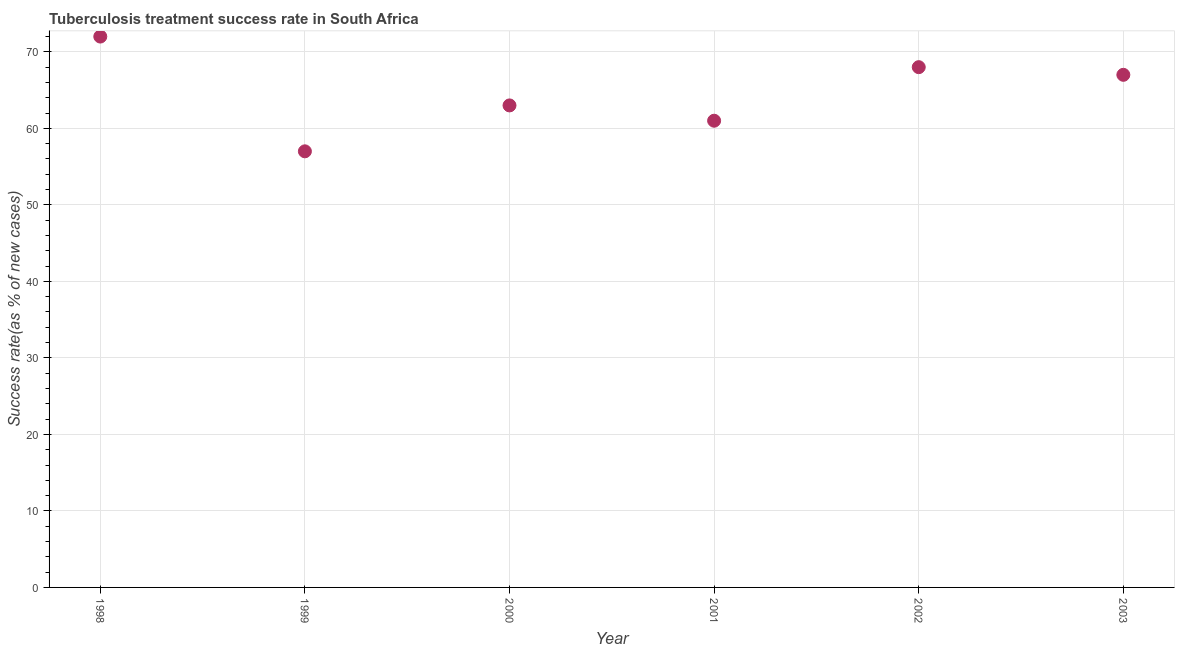What is the tuberculosis treatment success rate in 2002?
Provide a short and direct response. 68. Across all years, what is the maximum tuberculosis treatment success rate?
Give a very brief answer. 72. Across all years, what is the minimum tuberculosis treatment success rate?
Offer a very short reply. 57. In which year was the tuberculosis treatment success rate maximum?
Provide a succinct answer. 1998. What is the sum of the tuberculosis treatment success rate?
Give a very brief answer. 388. What is the difference between the tuberculosis treatment success rate in 1998 and 2000?
Keep it short and to the point. 9. What is the average tuberculosis treatment success rate per year?
Provide a succinct answer. 64.67. In how many years, is the tuberculosis treatment success rate greater than 16 %?
Provide a succinct answer. 6. Do a majority of the years between 1999 and 1998 (inclusive) have tuberculosis treatment success rate greater than 56 %?
Your answer should be very brief. No. What is the ratio of the tuberculosis treatment success rate in 2001 to that in 2003?
Ensure brevity in your answer.  0.91. Is the difference between the tuberculosis treatment success rate in 2002 and 2003 greater than the difference between any two years?
Offer a terse response. No. What is the difference between the highest and the second highest tuberculosis treatment success rate?
Offer a very short reply. 4. What is the difference between the highest and the lowest tuberculosis treatment success rate?
Keep it short and to the point. 15. Does the tuberculosis treatment success rate monotonically increase over the years?
Give a very brief answer. No. How many dotlines are there?
Make the answer very short. 1. How many years are there in the graph?
Your answer should be compact. 6. Does the graph contain any zero values?
Your answer should be very brief. No. Does the graph contain grids?
Give a very brief answer. Yes. What is the title of the graph?
Ensure brevity in your answer.  Tuberculosis treatment success rate in South Africa. What is the label or title of the X-axis?
Your answer should be very brief. Year. What is the label or title of the Y-axis?
Provide a succinct answer. Success rate(as % of new cases). What is the Success rate(as % of new cases) in 1999?
Your answer should be very brief. 57. What is the Success rate(as % of new cases) in 2000?
Your response must be concise. 63. What is the Success rate(as % of new cases) in 2001?
Offer a terse response. 61. What is the Success rate(as % of new cases) in 2002?
Give a very brief answer. 68. What is the Success rate(as % of new cases) in 2003?
Your answer should be very brief. 67. What is the difference between the Success rate(as % of new cases) in 1998 and 1999?
Your answer should be very brief. 15. What is the difference between the Success rate(as % of new cases) in 1998 and 2000?
Offer a terse response. 9. What is the difference between the Success rate(as % of new cases) in 1998 and 2002?
Offer a terse response. 4. What is the difference between the Success rate(as % of new cases) in 1999 and 2000?
Offer a terse response. -6. What is the difference between the Success rate(as % of new cases) in 1999 and 2001?
Offer a very short reply. -4. What is the difference between the Success rate(as % of new cases) in 1999 and 2003?
Provide a short and direct response. -10. What is the difference between the Success rate(as % of new cases) in 2001 and 2003?
Make the answer very short. -6. What is the difference between the Success rate(as % of new cases) in 2002 and 2003?
Provide a short and direct response. 1. What is the ratio of the Success rate(as % of new cases) in 1998 to that in 1999?
Your answer should be very brief. 1.26. What is the ratio of the Success rate(as % of new cases) in 1998 to that in 2000?
Your answer should be compact. 1.14. What is the ratio of the Success rate(as % of new cases) in 1998 to that in 2001?
Provide a succinct answer. 1.18. What is the ratio of the Success rate(as % of new cases) in 1998 to that in 2002?
Ensure brevity in your answer.  1.06. What is the ratio of the Success rate(as % of new cases) in 1998 to that in 2003?
Your answer should be compact. 1.07. What is the ratio of the Success rate(as % of new cases) in 1999 to that in 2000?
Offer a terse response. 0.91. What is the ratio of the Success rate(as % of new cases) in 1999 to that in 2001?
Make the answer very short. 0.93. What is the ratio of the Success rate(as % of new cases) in 1999 to that in 2002?
Provide a succinct answer. 0.84. What is the ratio of the Success rate(as % of new cases) in 1999 to that in 2003?
Give a very brief answer. 0.85. What is the ratio of the Success rate(as % of new cases) in 2000 to that in 2001?
Your response must be concise. 1.03. What is the ratio of the Success rate(as % of new cases) in 2000 to that in 2002?
Provide a succinct answer. 0.93. What is the ratio of the Success rate(as % of new cases) in 2000 to that in 2003?
Offer a terse response. 0.94. What is the ratio of the Success rate(as % of new cases) in 2001 to that in 2002?
Keep it short and to the point. 0.9. What is the ratio of the Success rate(as % of new cases) in 2001 to that in 2003?
Give a very brief answer. 0.91. What is the ratio of the Success rate(as % of new cases) in 2002 to that in 2003?
Ensure brevity in your answer.  1.01. 